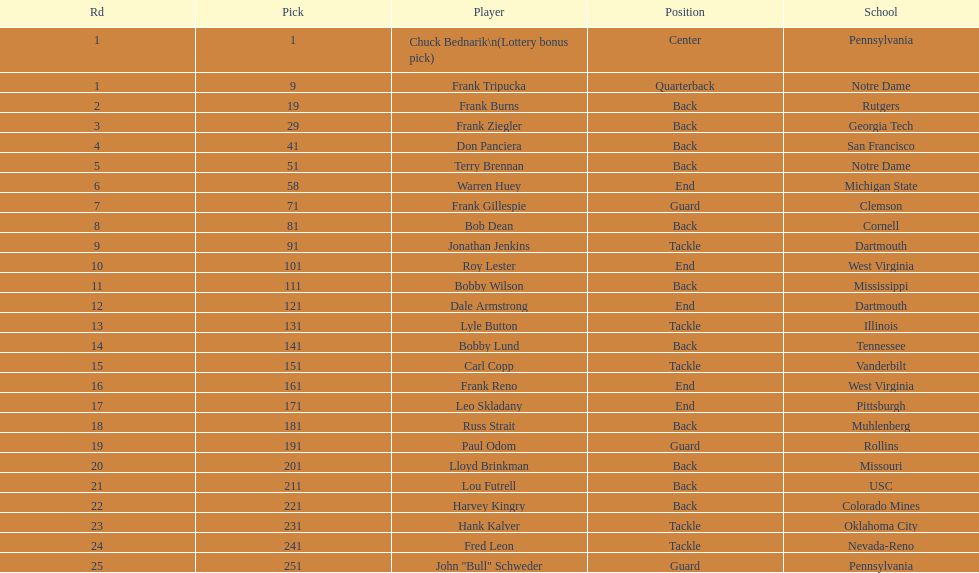What is the most common school type? Pennsylvania. 